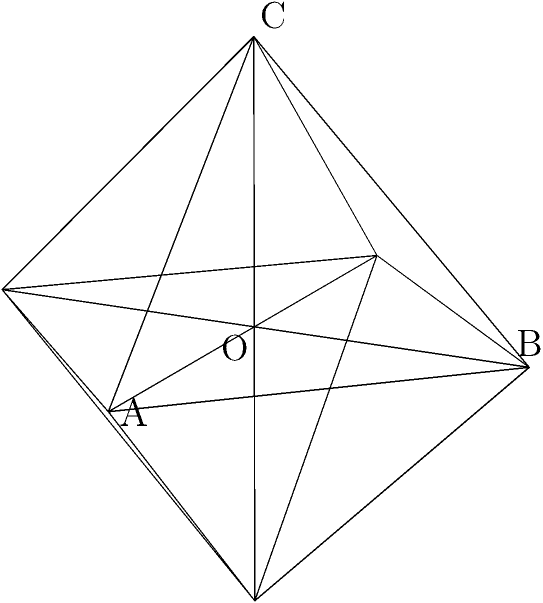In a regular octahedron with side length $a$, calculate the angle between two adjacent faces, such as face ABC and face ABO. How might this calculation be relevant in designing efficient 3D models for resource-constrained AI applications? Let's approach this step-by-step:

1) In a regular octahedron, the center O is equidistant from all vertices. Let this distance be $r$.

2) The octahedron can be inscribed in a cube of side length $a$. This gives us:
   $$r = \frac{a\sqrt{2}}{2}$$

3) The coordinates of vertices A, B, and C in terms of $r$ are:
   A: $(r, 0, 0)$
   B: $(0, r, 0)$
   C: $(0, 0, r)$

4) The normal vectors to faces ABC and ABO are:
   $\vec{n_1} = \vec{OA} + \vec{OB} + \vec{OC} = (r, r, r)$
   $\vec{n_2} = \vec{OA} + \vec{OB} - \vec{OC} = (r, r, -r)$

5) The angle $\theta$ between these faces is the supplement of the angle between their normal vectors:
   $$\cos \theta = -\frac{\vec{n_1} \cdot \vec{n_2}}{|\vec{n_1}||\vec{n_2}|}$$

6) Calculating:
   $$\cos \theta = -\frac{r^2 + r^2 - r^2}{(r^2 + r^2 + r^2)(r^2 + r^2 + r^2)} = -\frac{1}{3}$$

7) Therefore:
   $$\theta = \arccos(-\frac{1}{3}) \approx 109.47°$$

This calculation is relevant in resource-constrained AI applications because:

1) Efficient 3D modeling: Understanding geometric properties helps in creating compact 3D representations, crucial for limited storage and processing power.

2) Optimization: Knowing exact angles aids in optimizing algorithms for 3D object recognition or manipulation tasks.

3) Local context: In developing countries, applications might involve 3D modeling of local architecture or artifacts, where precise geometry is important.
Answer: $\arccos(-\frac{1}{3}) \approx 109.47°$ 